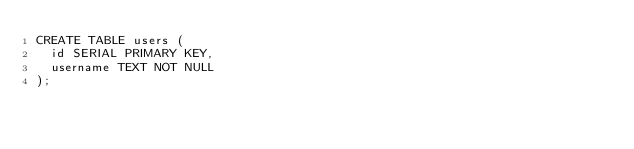<code> <loc_0><loc_0><loc_500><loc_500><_SQL_>CREATE TABLE users (
  id SERIAL PRIMARY KEY,
  username TEXT NOT NULL
);
</code> 